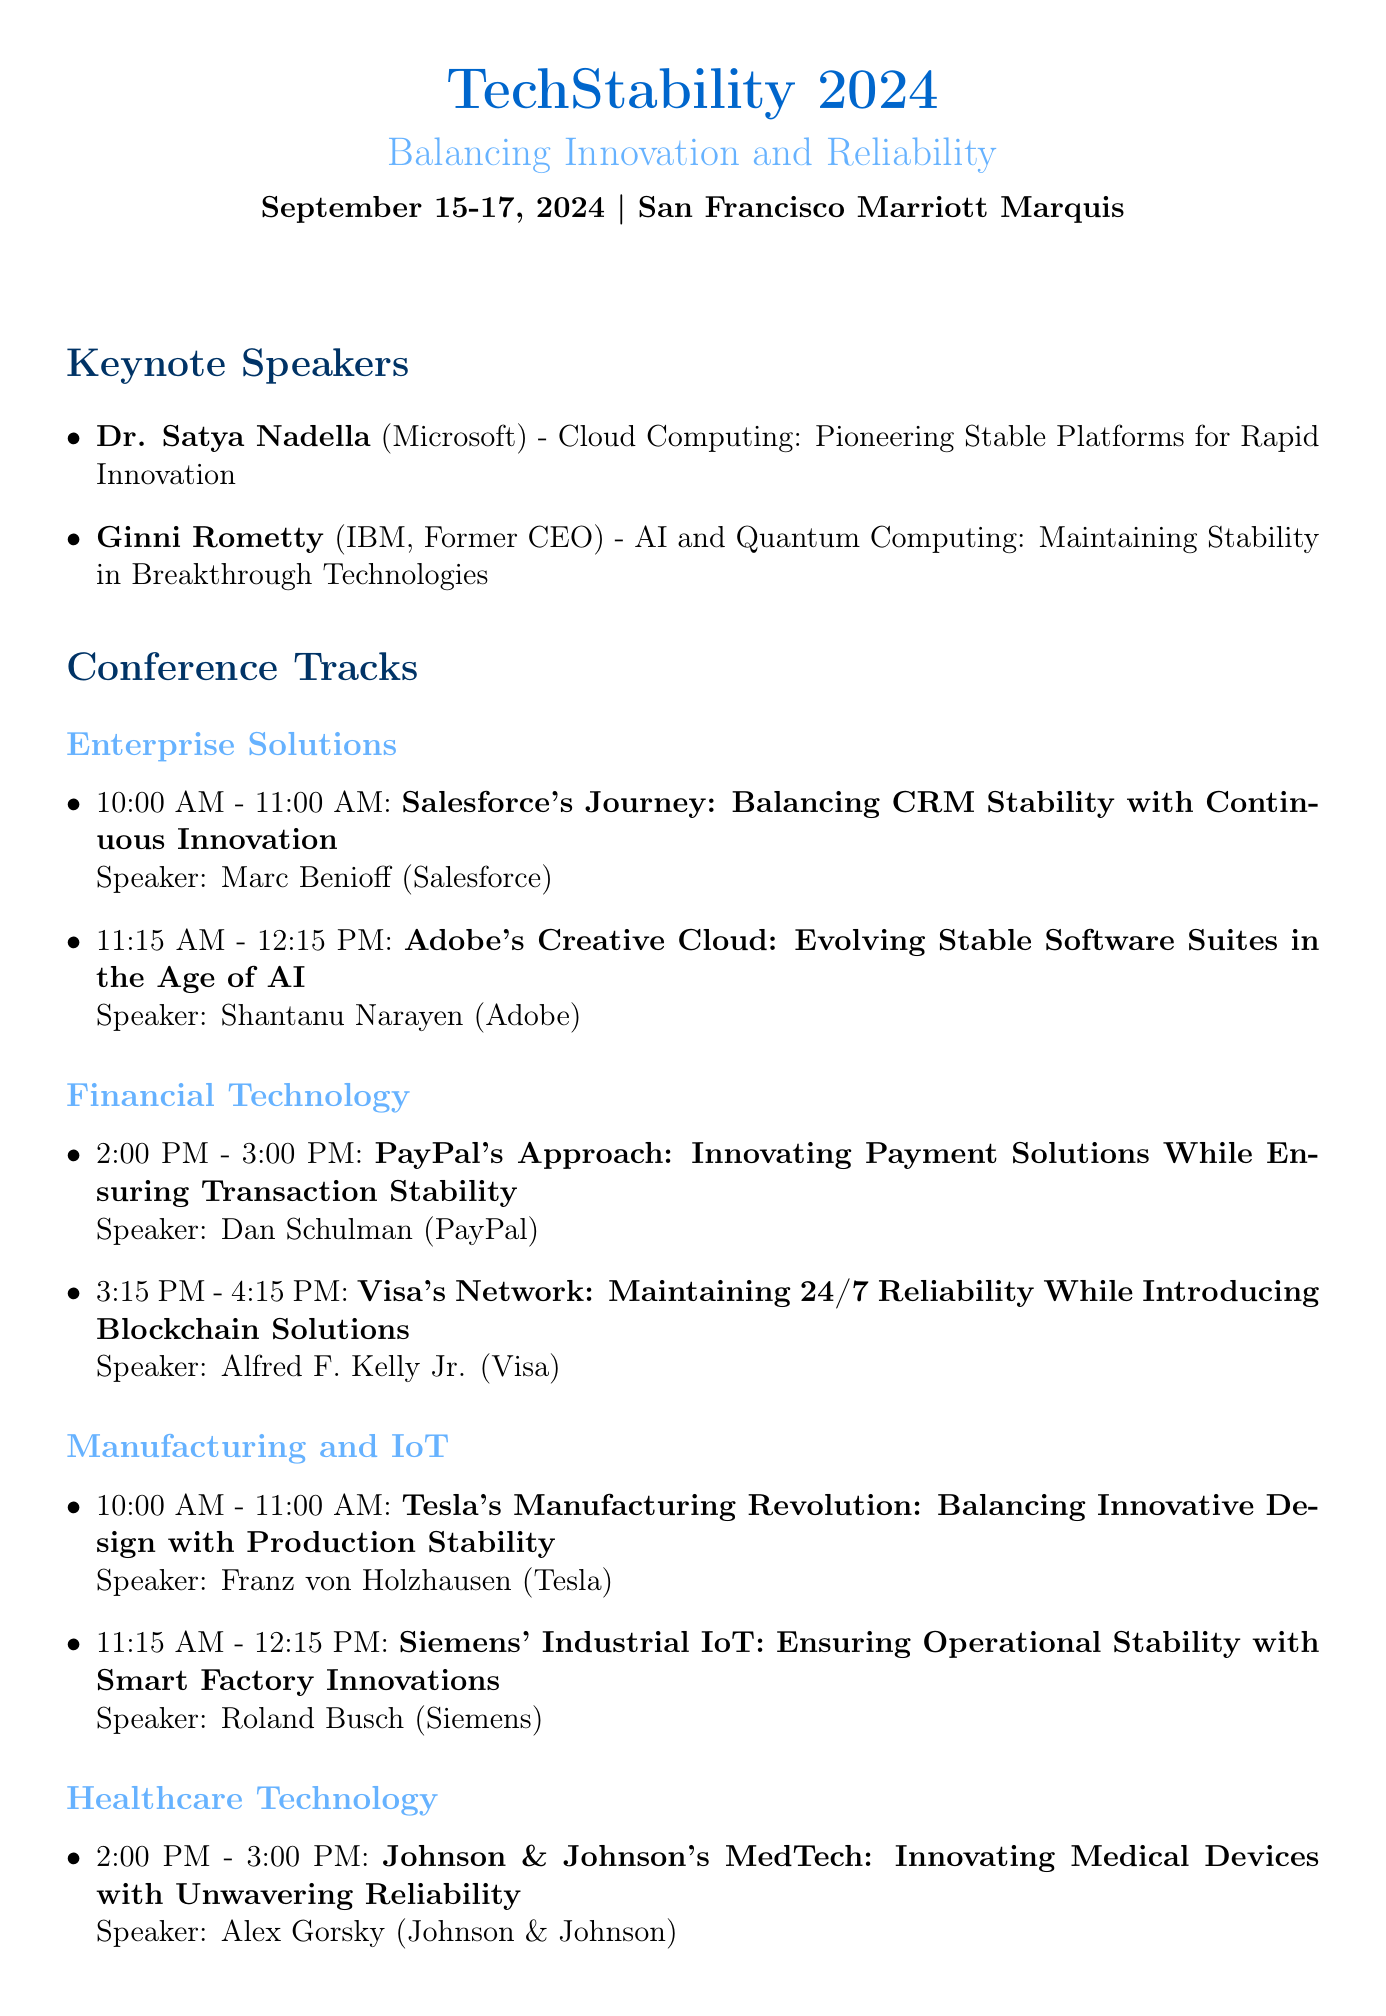What are the dates of the conference? The document states that the conference will take place from September 15 to September 17, 2024.
Answer: September 15-17, 2024 Who is the keynote speaker from Microsoft? The document lists Dr. Satya Nadella as the keynote speaker from Microsoft.
Answer: Dr. Satya Nadella What is the title of the panel discussion? The panel discussion is titled "Achieving Stability-Innovation Synergy in Highly Regulated Industries."
Answer: Achieving Stability-Innovation Synergy in Highly Regulated Industries What session occurs at 2:00 PM on September 16? The session titled "PayPal's Approach: Innovating Payment Solutions While Ensuring Transaction Stability" occurs at this time.
Answer: PayPal's Approach: Innovating Payment Solutions While Ensuring Transaction Stability Which company does Judy Faulkner represent? The document identifies Judy Faulkner as representing Epic Systems.
Answer: Epic Systems Who is moderating the panel discussion? Safra Catz is mentioned as the moderator for the panel discussion.
Answer: Safra Catz What time is the Welcome Reception? The Welcome Reception is scheduled from 7:00 PM to 9:00 PM.
Answer: 7:00 PM - 9:00 PM What is the theme of TechStability 2024? The theme is "Balancing Innovation and Reliability."
Answer: Balancing Innovation and Reliability 